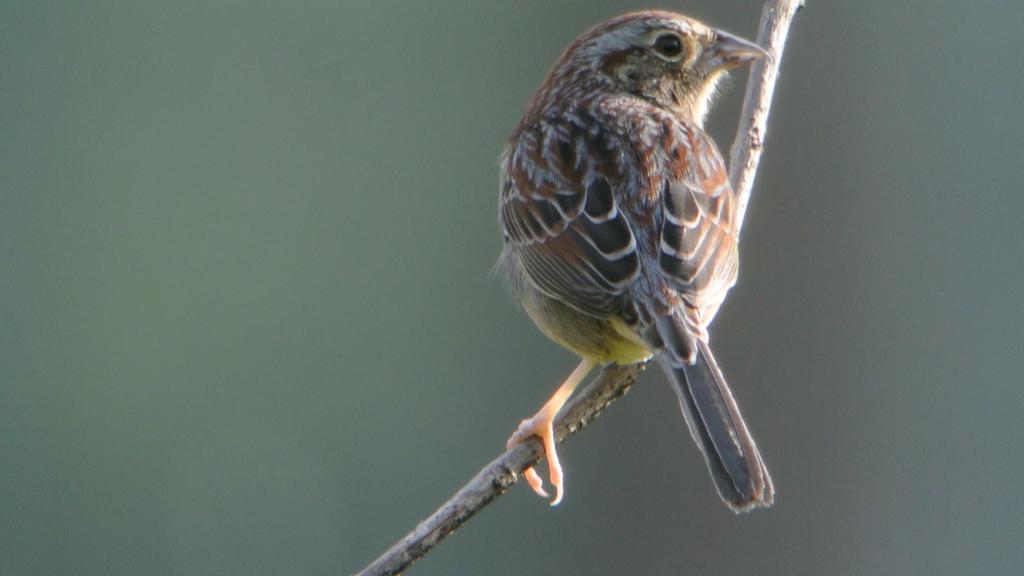In one or two sentences, can you explain what this image depicts? In the image I can see a bird sitting on a branch. The background of the image is blurred. 